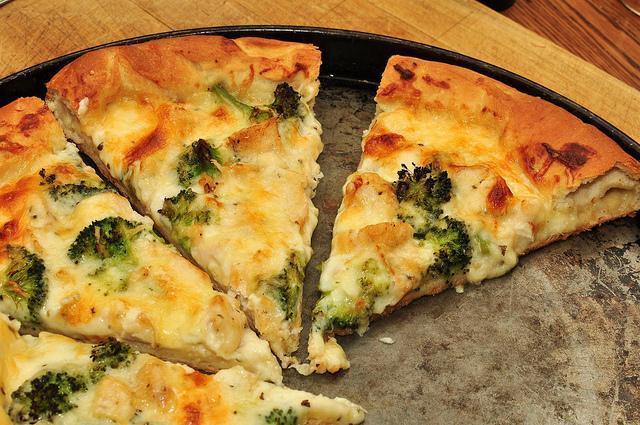How many pizzas are in the picture?
Give a very brief answer. 3. How many broccolis are there?
Give a very brief answer. 5. How many dining tables are there?
Give a very brief answer. 2. 